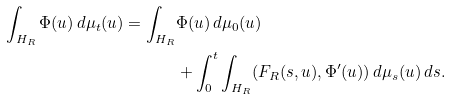<formula> <loc_0><loc_0><loc_500><loc_500>\int _ { H _ { R } } \Phi ( u ) \, d \mu _ { t } ( u ) = \int _ { H _ { R } } & \Phi ( u ) \, d \mu _ { 0 } ( u ) \\ & + \int _ { 0 } ^ { t } \int _ { H _ { R } } ( F _ { R } ( s , u ) , \Phi ^ { \prime } ( u ) ) \, d \mu _ { s } ( u ) \, d s .</formula> 